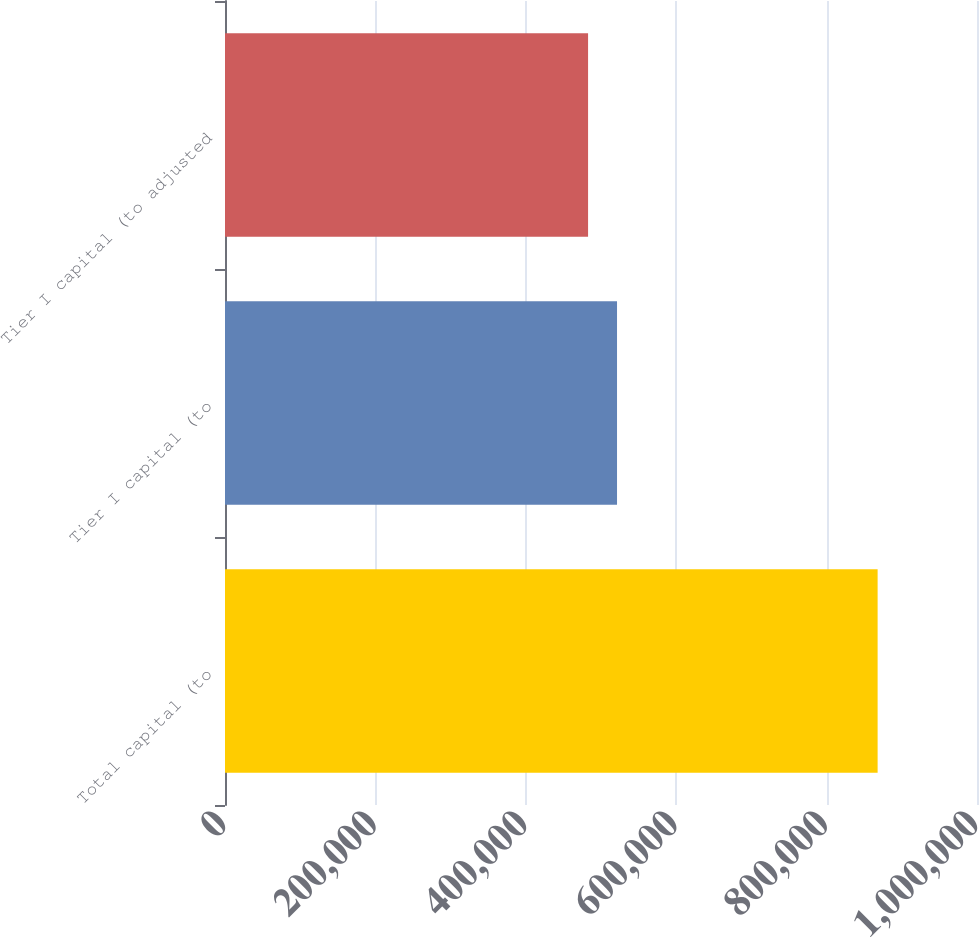Convert chart. <chart><loc_0><loc_0><loc_500><loc_500><bar_chart><fcel>Total capital (to<fcel>Tier I capital (to<fcel>Tier I capital (to adjusted<nl><fcel>867844<fcel>521311<fcel>482807<nl></chart> 